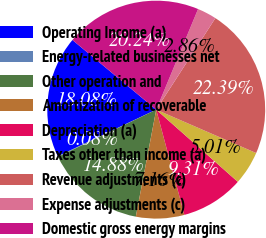Convert chart to OTSL. <chart><loc_0><loc_0><loc_500><loc_500><pie_chart><fcel>Operating Income (a)<fcel>Energy-related businesses net<fcel>Other operation and<fcel>Amortization of recoverable<fcel>Depreciation (a)<fcel>Taxes other than income (a)<fcel>Revenue adjustments (c)<fcel>Expense adjustments (c)<fcel>Domestic gross energy margins<nl><fcel>18.08%<fcel>0.08%<fcel>14.88%<fcel>7.16%<fcel>9.31%<fcel>5.01%<fcel>22.39%<fcel>2.86%<fcel>20.24%<nl></chart> 